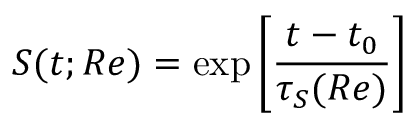<formula> <loc_0><loc_0><loc_500><loc_500>S ( t ; R e ) = \exp \left [ \frac { t - t _ { 0 } } { \tau _ { S } ( R e ) } \right ]</formula> 